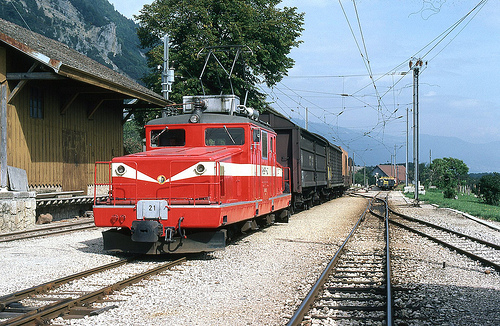Does the train look black and small? No, the train in the image is not black and small; it is rather large and red, standing out distinctly against the green landscape. 